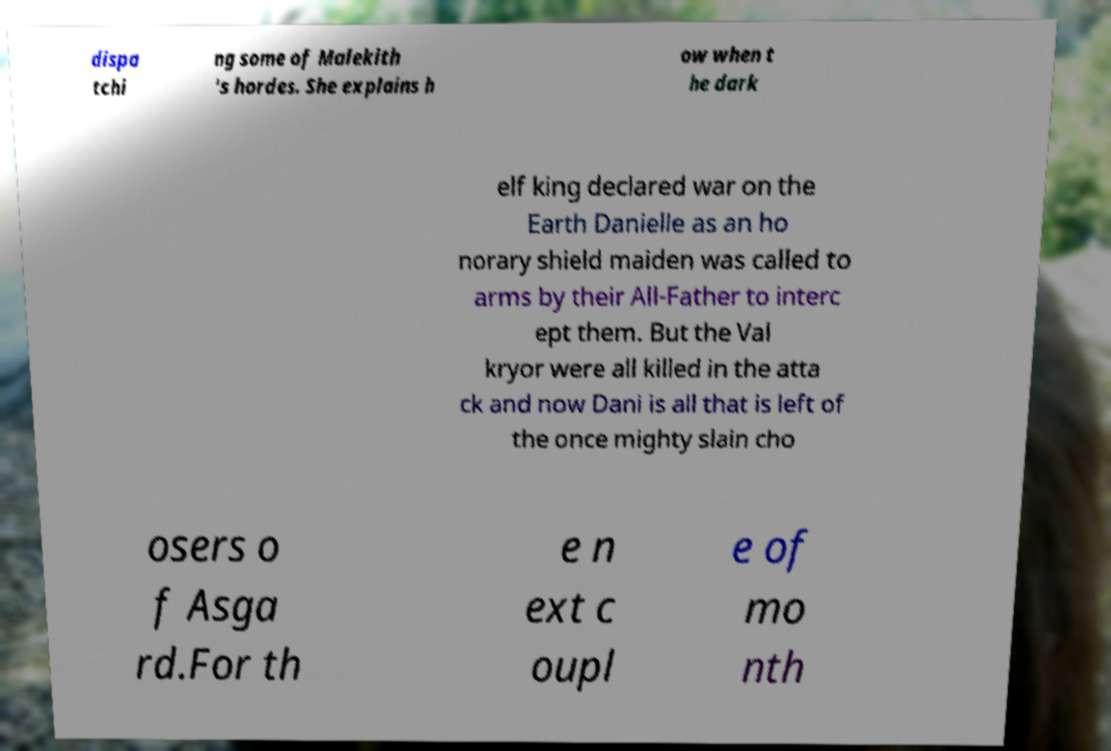Could you extract and type out the text from this image? dispa tchi ng some of Malekith 's hordes. She explains h ow when t he dark elf king declared war on the Earth Danielle as an ho norary shield maiden was called to arms by their All-Father to interc ept them. But the Val kryor were all killed in the atta ck and now Dani is all that is left of the once mighty slain cho osers o f Asga rd.For th e n ext c oupl e of mo nth 